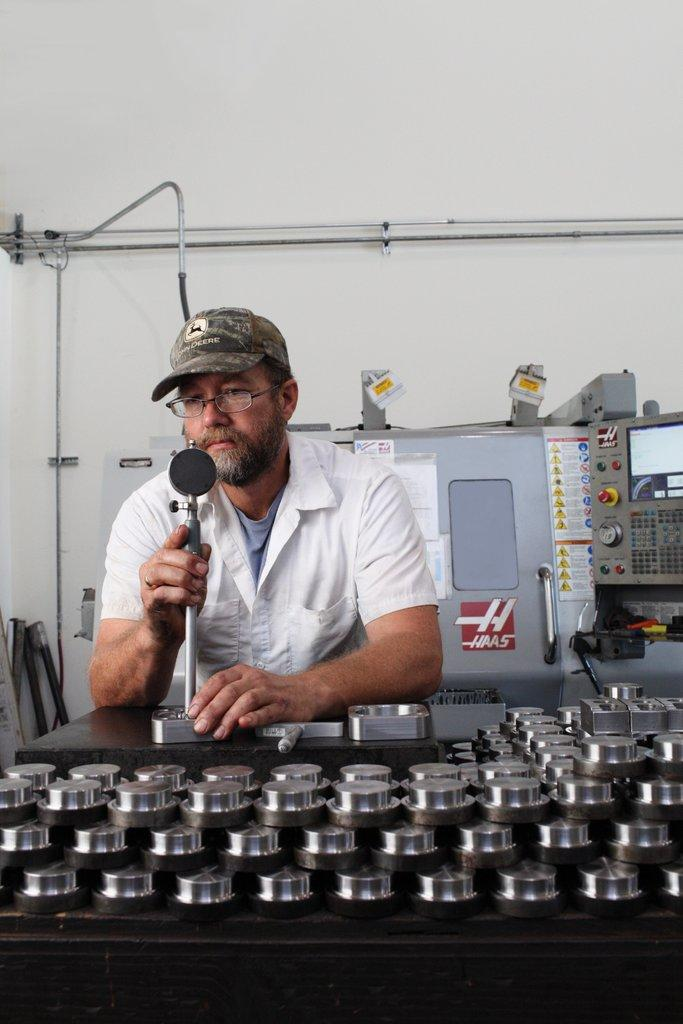What is the person in the image holding? The person is holding something in the image, but the specific object is not mentioned in the facts. What colors can be seen in the objects in the image? The objects in the image have silver and black colors. What can be seen in the background of the image? There are machines and a wall visible in the background of the image. Can you see a crown on the person's head in the image? There is no mention of a crown in the image, so it cannot be confirmed or denied. 